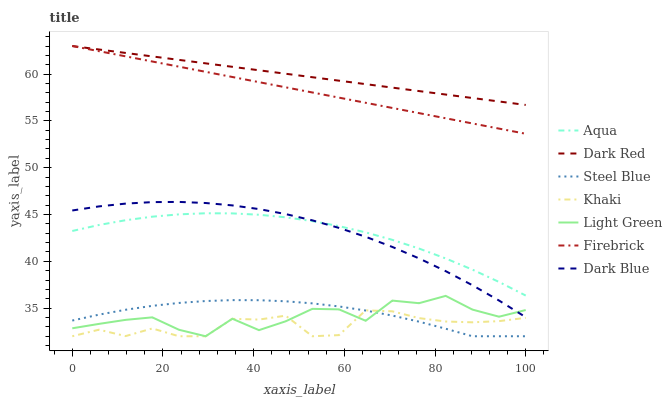Does Khaki have the minimum area under the curve?
Answer yes or no. Yes. Does Dark Red have the maximum area under the curve?
Answer yes or no. Yes. Does Firebrick have the minimum area under the curve?
Answer yes or no. No. Does Firebrick have the maximum area under the curve?
Answer yes or no. No. Is Dark Red the smoothest?
Answer yes or no. Yes. Is Light Green the roughest?
Answer yes or no. Yes. Is Firebrick the smoothest?
Answer yes or no. No. Is Firebrick the roughest?
Answer yes or no. No. Does Khaki have the lowest value?
Answer yes or no. Yes. Does Firebrick have the lowest value?
Answer yes or no. No. Does Firebrick have the highest value?
Answer yes or no. Yes. Does Aqua have the highest value?
Answer yes or no. No. Is Aqua less than Firebrick?
Answer yes or no. Yes. Is Firebrick greater than Khaki?
Answer yes or no. Yes. Does Light Green intersect Dark Blue?
Answer yes or no. Yes. Is Light Green less than Dark Blue?
Answer yes or no. No. Is Light Green greater than Dark Blue?
Answer yes or no. No. Does Aqua intersect Firebrick?
Answer yes or no. No. 